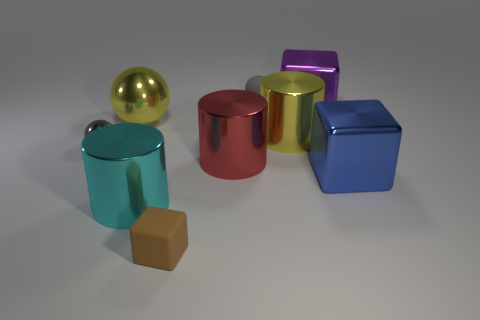Add 1 gray metal balls. How many objects exist? 10 Subtract all cubes. How many objects are left? 6 Add 2 large blue things. How many large blue things are left? 3 Add 2 small red shiny objects. How many small red shiny objects exist? 2 Subtract 0 purple spheres. How many objects are left? 9 Subtract all brown objects. Subtract all cyan metallic objects. How many objects are left? 7 